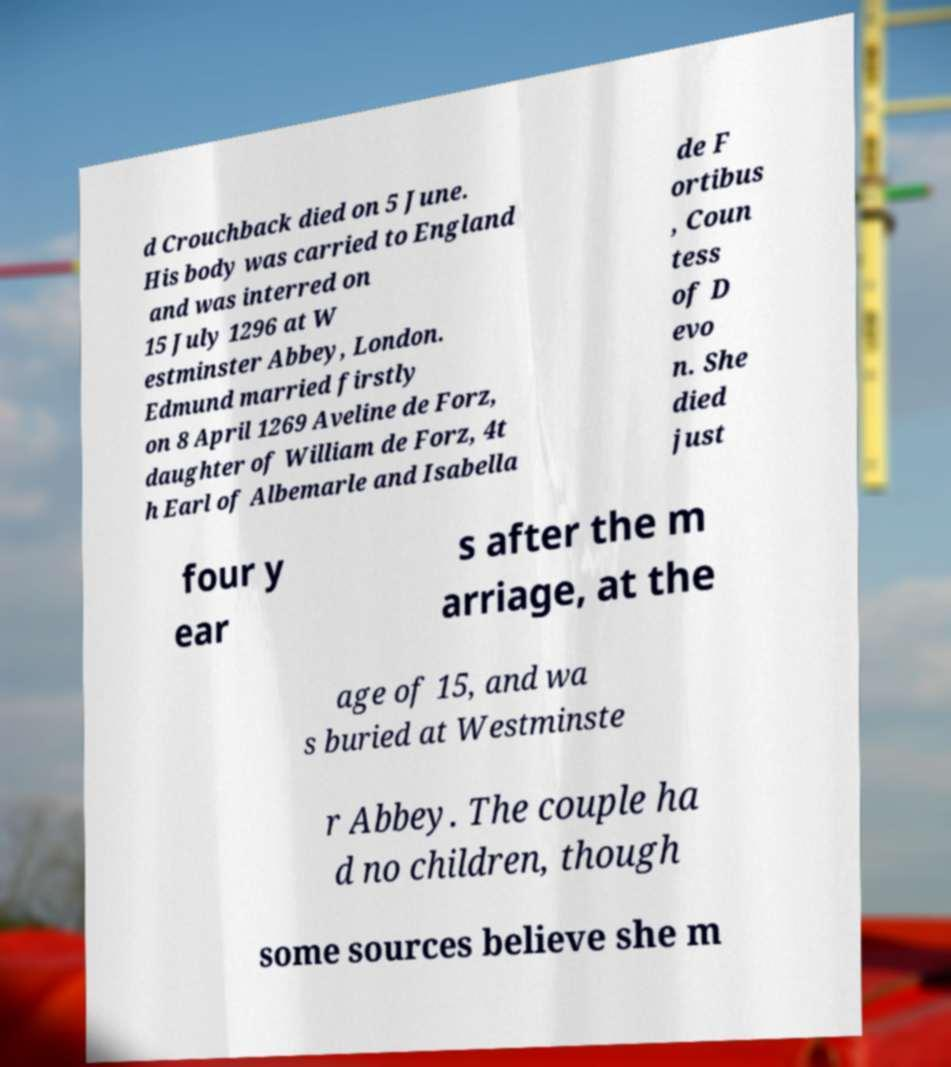Could you assist in decoding the text presented in this image and type it out clearly? d Crouchback died on 5 June. His body was carried to England and was interred on 15 July 1296 at W estminster Abbey, London. Edmund married firstly on 8 April 1269 Aveline de Forz, daughter of William de Forz, 4t h Earl of Albemarle and Isabella de F ortibus , Coun tess of D evo n. She died just four y ear s after the m arriage, at the age of 15, and wa s buried at Westminste r Abbey. The couple ha d no children, though some sources believe she m 